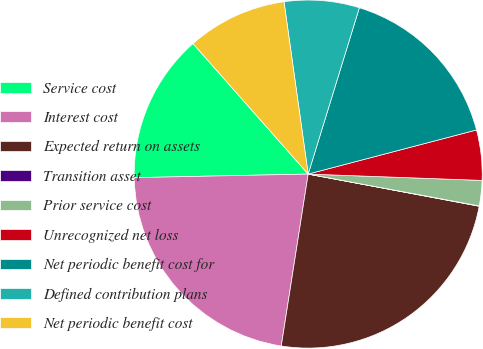<chart> <loc_0><loc_0><loc_500><loc_500><pie_chart><fcel>Service cost<fcel>Interest cost<fcel>Expected return on assets<fcel>Transition asset<fcel>Prior service cost<fcel>Unrecognized net loss<fcel>Net periodic benefit cost for<fcel>Defined contribution plans<fcel>Net periodic benefit cost<nl><fcel>13.82%<fcel>22.2%<fcel>24.51%<fcel>0.03%<fcel>2.35%<fcel>4.66%<fcel>16.17%<fcel>6.97%<fcel>9.29%<nl></chart> 